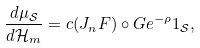<formula> <loc_0><loc_0><loc_500><loc_500>\frac { d \mu _ { \mathcal { S } } } { d \mathcal { H } _ { m } } = c ( J _ { n } F ) \circ G e ^ { - \rho } 1 _ { \mathcal { S } } ,</formula> 